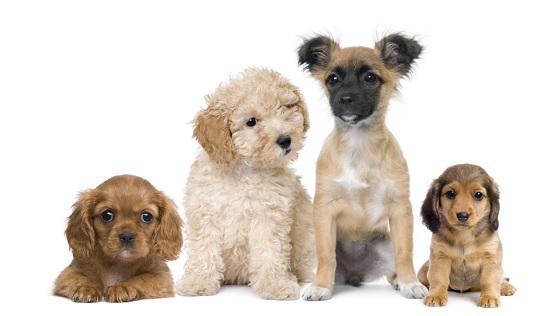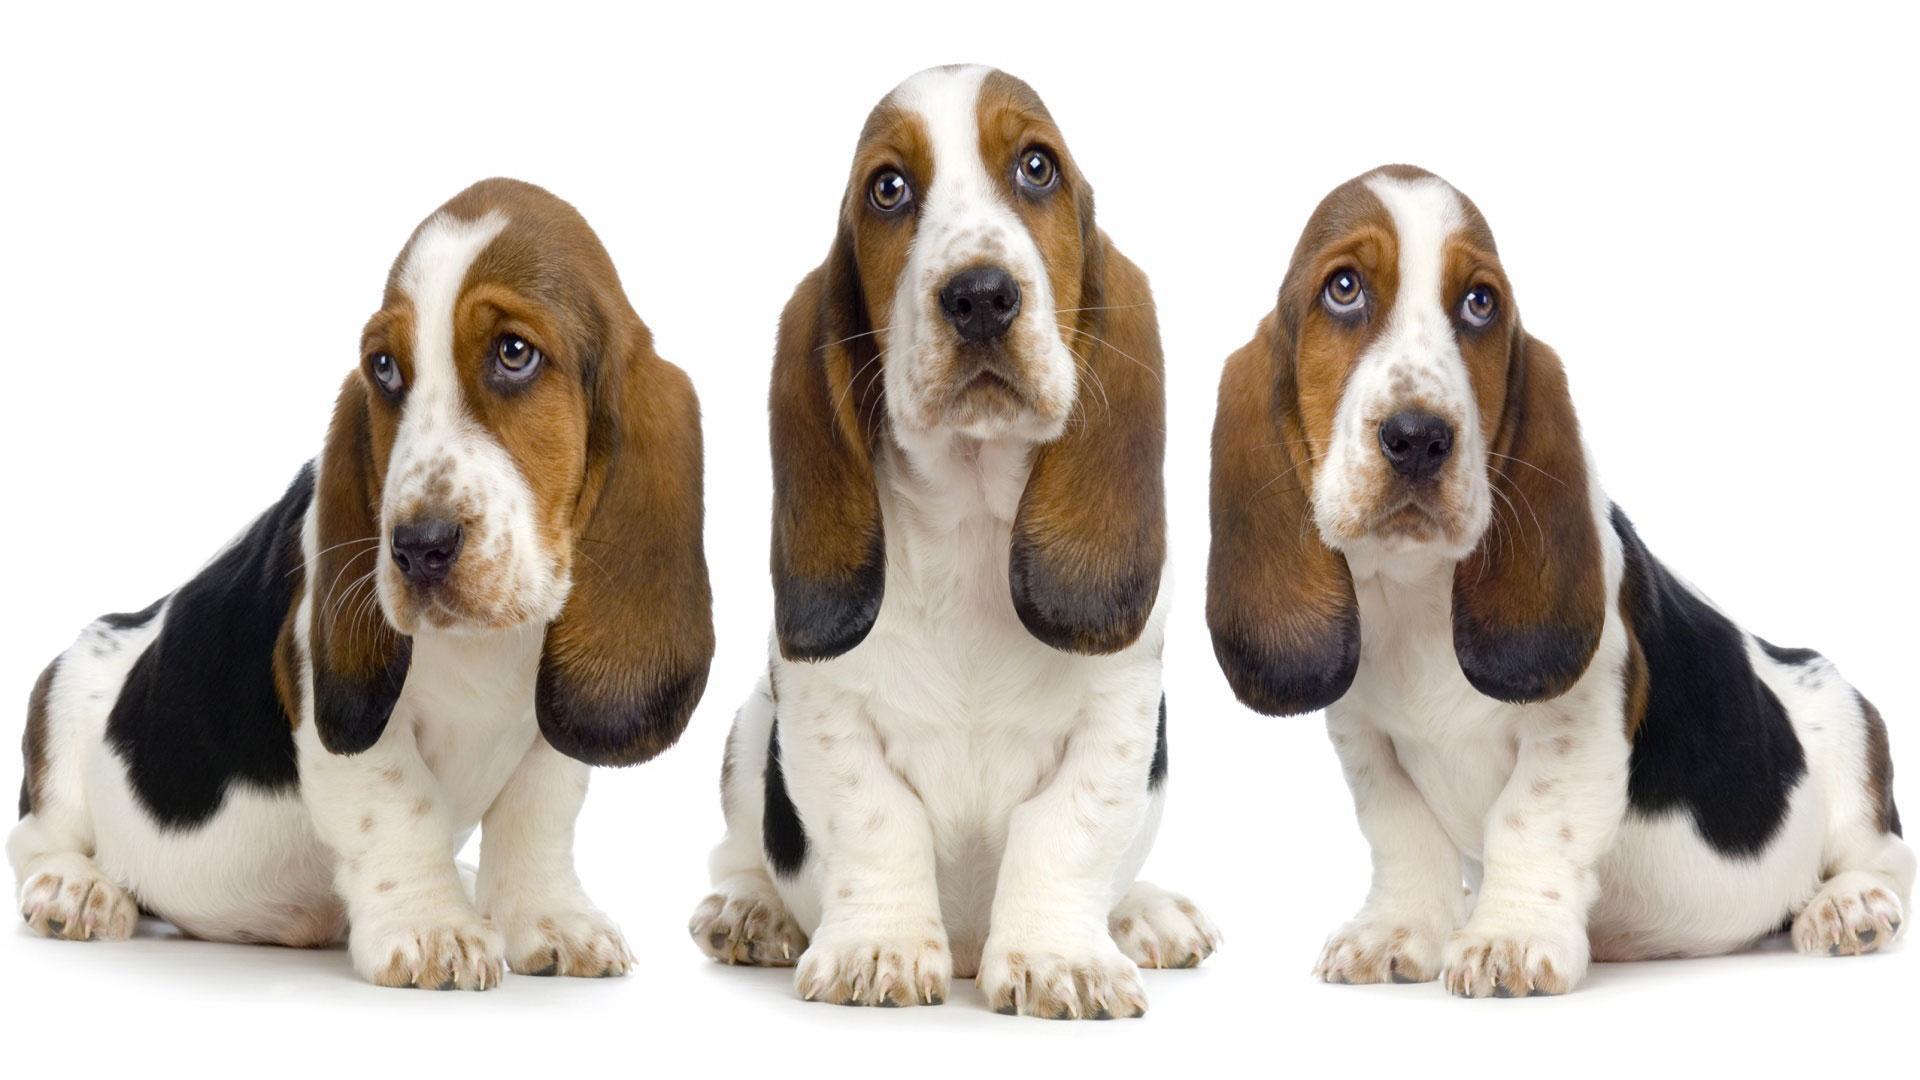The first image is the image on the left, the second image is the image on the right. Given the left and right images, does the statement "There are at least seven dogs." hold true? Answer yes or no. Yes. 